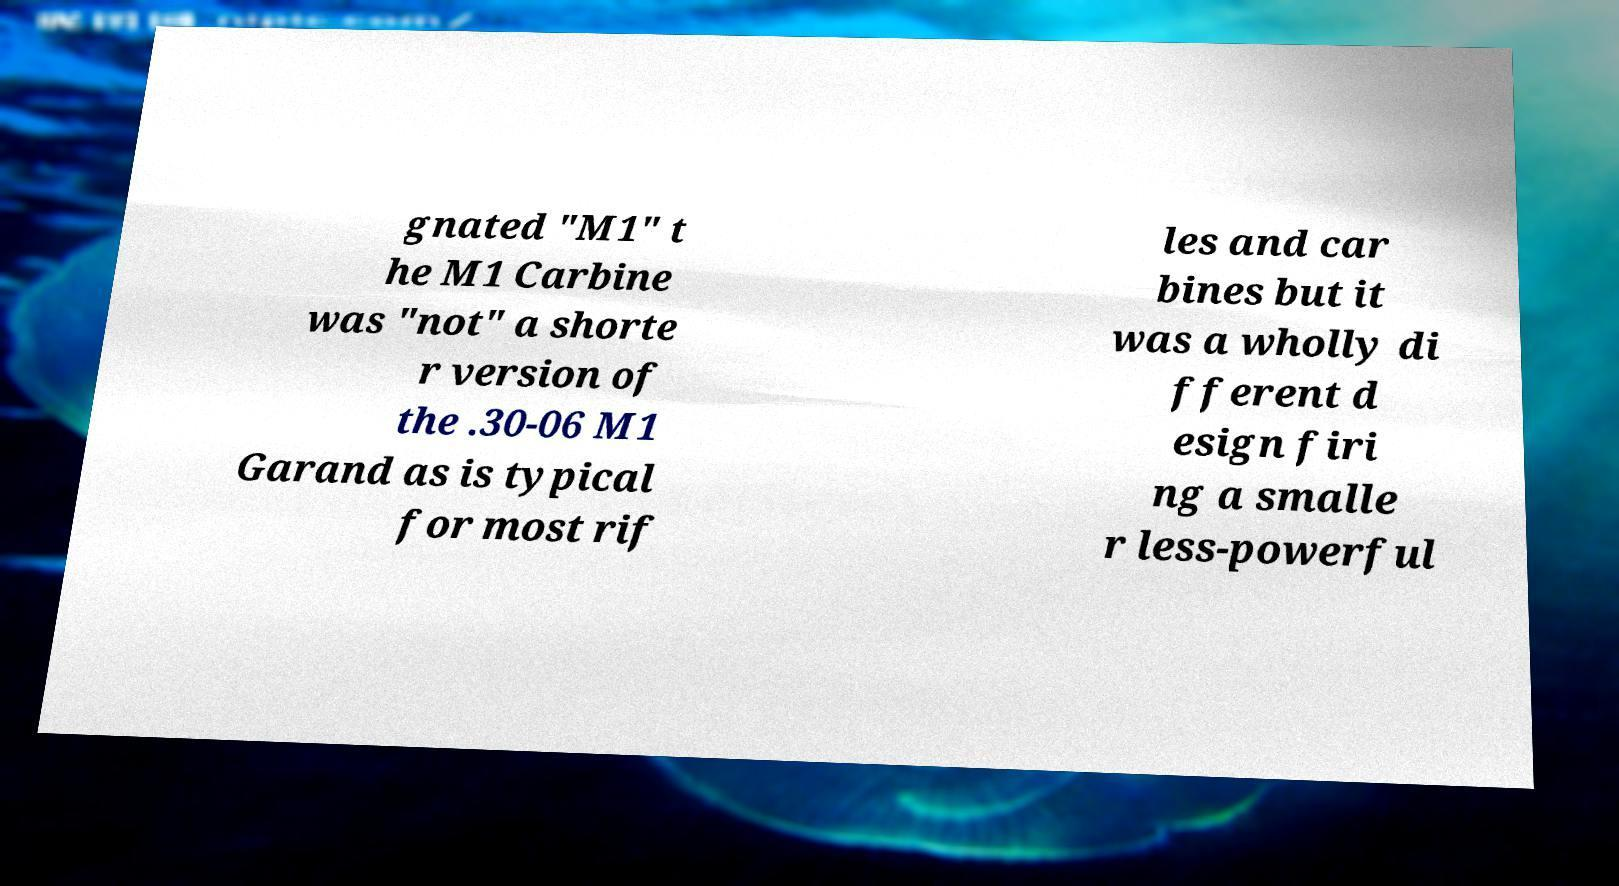There's text embedded in this image that I need extracted. Can you transcribe it verbatim? gnated "M1" t he M1 Carbine was "not" a shorte r version of the .30-06 M1 Garand as is typical for most rif les and car bines but it was a wholly di fferent d esign firi ng a smalle r less-powerful 